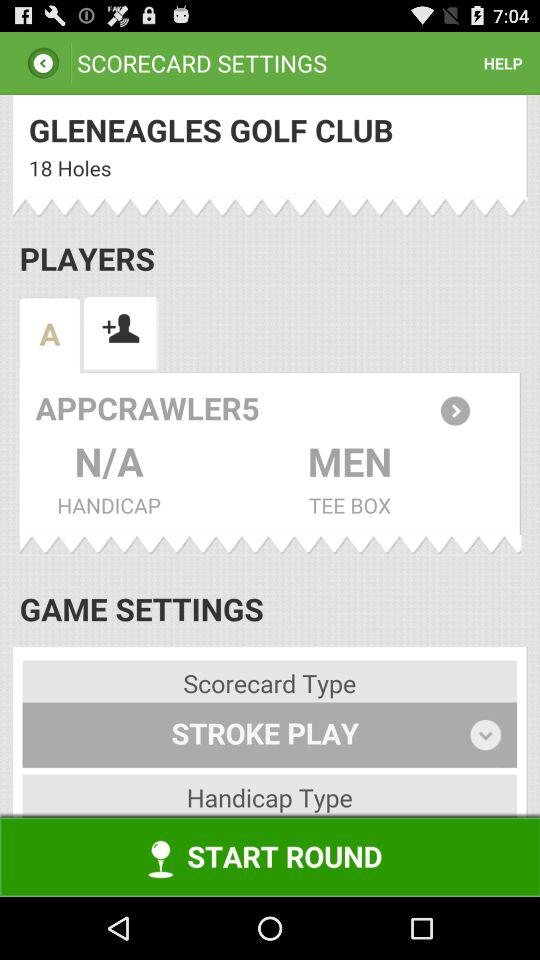Which option is selected in the game setting? The selected option is "STROKE PLAY". 